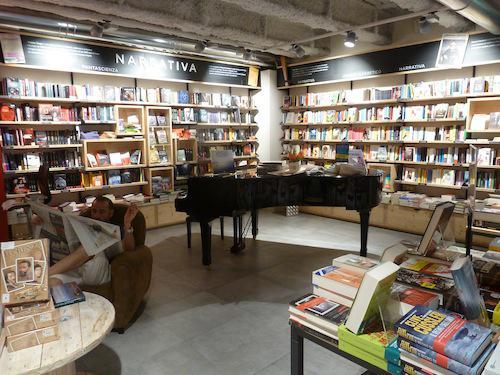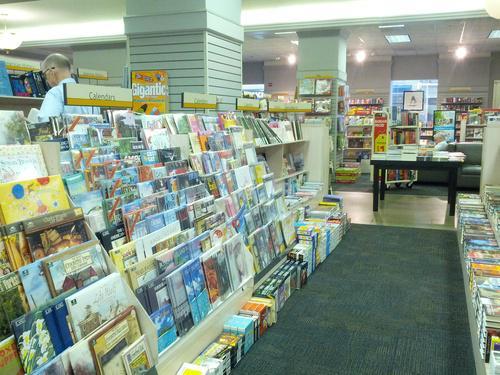The first image is the image on the left, the second image is the image on the right. Assess this claim about the two images: "There are multiple people in a shop in the right image.". Correct or not? Answer yes or no. No. 